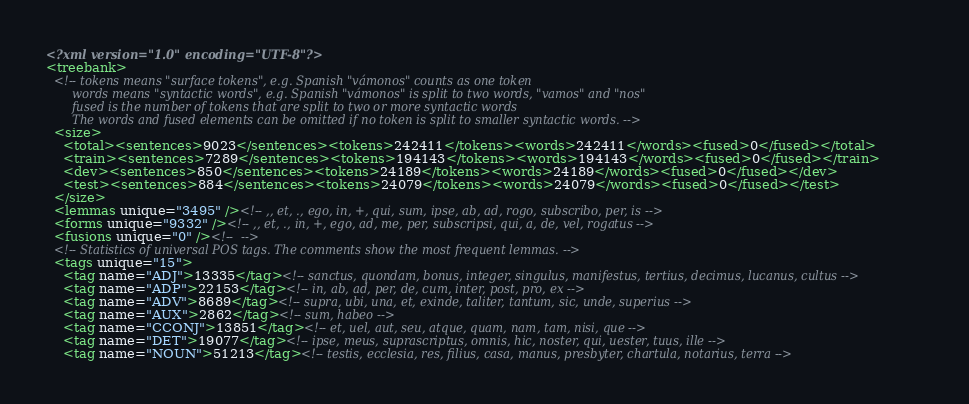<code> <loc_0><loc_0><loc_500><loc_500><_XML_><?xml version="1.0" encoding="UTF-8"?>
<treebank>
  <!-- tokens means "surface tokens", e.g. Spanish "vámonos" counts as one token
       words means "syntactic words", e.g. Spanish "vámonos" is split to two words, "vamos" and "nos"
       fused is the number of tokens that are split to two or more syntactic words
       The words and fused elements can be omitted if no token is split to smaller syntactic words. -->
  <size>
    <total><sentences>9023</sentences><tokens>242411</tokens><words>242411</words><fused>0</fused></total>
    <train><sentences>7289</sentences><tokens>194143</tokens><words>194143</words><fused>0</fused></train>
    <dev><sentences>850</sentences><tokens>24189</tokens><words>24189</words><fused>0</fused></dev>
    <test><sentences>884</sentences><tokens>24079</tokens><words>24079</words><fused>0</fused></test>
  </size>
  <lemmas unique="3495" /><!-- ,, et, ., ego, in, +, qui, sum, ipse, ab, ad, rogo, subscribo, per, is -->
  <forms unique="9332" /><!-- ,, et, ., in, +, ego, ad, me, per, subscripsi, qui, a, de, vel, rogatus -->
  <fusions unique="0" /><!--  -->
  <!-- Statistics of universal POS tags. The comments show the most frequent lemmas. -->
  <tags unique="15">
    <tag name="ADJ">13335</tag><!-- sanctus, quondam, bonus, integer, singulus, manifestus, tertius, decimus, lucanus, cultus -->
    <tag name="ADP">22153</tag><!-- in, ab, ad, per, de, cum, inter, post, pro, ex -->
    <tag name="ADV">8689</tag><!-- supra, ubi, una, et, exinde, taliter, tantum, sic, unde, superius -->
    <tag name="AUX">2862</tag><!-- sum, habeo -->
    <tag name="CCONJ">13851</tag><!-- et, uel, aut, seu, atque, quam, nam, tam, nisi, que -->
    <tag name="DET">19077</tag><!-- ipse, meus, suprascriptus, omnis, hic, noster, qui, uester, tuus, ille -->
    <tag name="NOUN">51213</tag><!-- testis, ecclesia, res, filius, casa, manus, presbyter, chartula, notarius, terra --></code> 